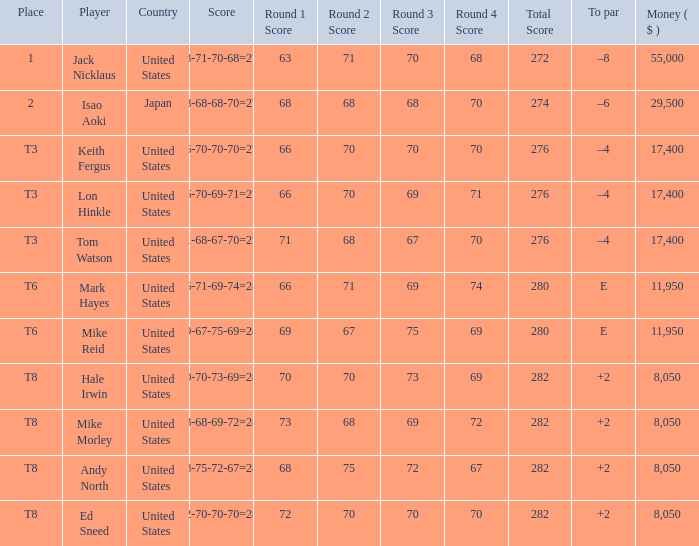Could you parse the entire table? {'header': ['Place', 'Player', 'Country', 'Score', 'Round 1 Score', 'Round 2 Score', 'Round 3 Score', 'Round 4 Score', 'Total Score', 'To par', 'Money ( $ )'], 'rows': [['1', 'Jack Nicklaus', 'United States', '63-71-70-68=272', '63', '71', '70', '68', '272', '–8', '55,000'], ['2', 'Isao Aoki', 'Japan', '68-68-68-70=274', '68', '68', '68', '70', '274', '–6', '29,500'], ['T3', 'Keith Fergus', 'United States', '66-70-70-70=276', '66', '70', '70', '70', '276', '–4', '17,400'], ['T3', 'Lon Hinkle', 'United States', '66-70-69-71=276', '66', '70', '69', '71', '276', '–4', '17,400'], ['T3', 'Tom Watson', 'United States', '71-68-67-70=276', '71', '68', '67', '70', '276', '–4', '17,400'], ['T6', 'Mark Hayes', 'United States', '66-71-69-74=280', '66', '71', '69', '74', '280', 'E', '11,950'], ['T6', 'Mike Reid', 'United States', '69-67-75-69=280', '69', '67', '75', '69', '280', 'E', '11,950'], ['T8', 'Hale Irwin', 'United States', '70-70-73-69=282', '70', '70', '73', '69', '282', '+2', '8,050'], ['T8', 'Mike Morley', 'United States', '73-68-69-72=282', '73', '68', '69', '72', '282', '+2', '8,050'], ['T8', 'Andy North', 'United States', '68-75-72-67=282', '68', '75', '72', '67', '282', '+2', '8,050'], ['T8', 'Ed Sneed', 'United States', '72-70-70-70=282', '72', '70', '70', '70', '282', '+2', '8,050']]} What country has the score og 66-70-69-71=276? United States. 